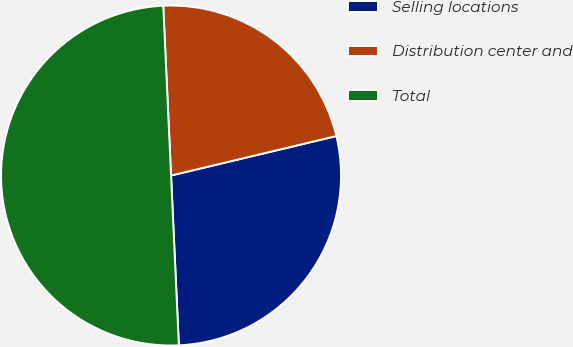Convert chart. <chart><loc_0><loc_0><loc_500><loc_500><pie_chart><fcel>Selling locations<fcel>Distribution center and<fcel>Total<nl><fcel>28.0%<fcel>22.0%<fcel>50.0%<nl></chart> 